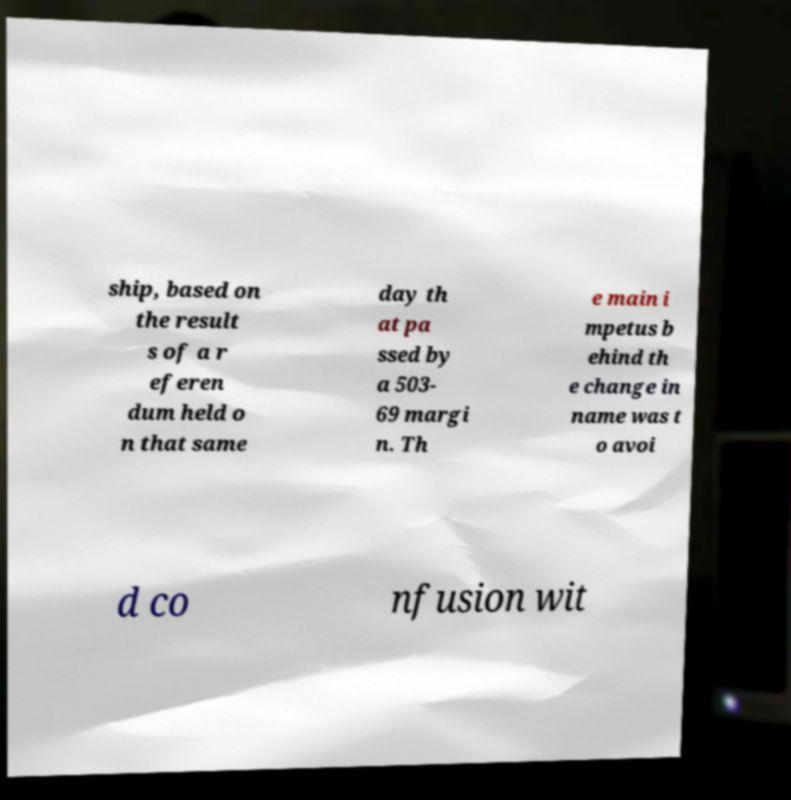There's text embedded in this image that I need extracted. Can you transcribe it verbatim? ship, based on the result s of a r eferen dum held o n that same day th at pa ssed by a 503- 69 margi n. Th e main i mpetus b ehind th e change in name was t o avoi d co nfusion wit 